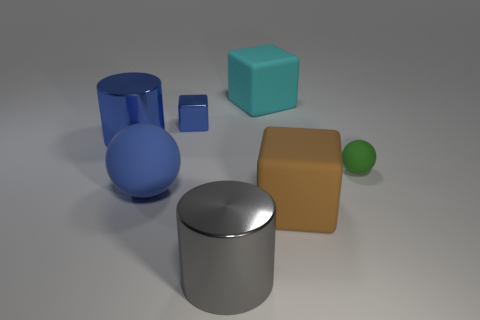Add 1 brown cubes. How many objects exist? 8 Subtract all blocks. How many objects are left? 4 Subtract all large red blocks. Subtract all blue matte objects. How many objects are left? 6 Add 6 big rubber objects. How many big rubber objects are left? 9 Add 6 tiny brown blocks. How many tiny brown blocks exist? 6 Subtract 0 green cylinders. How many objects are left? 7 